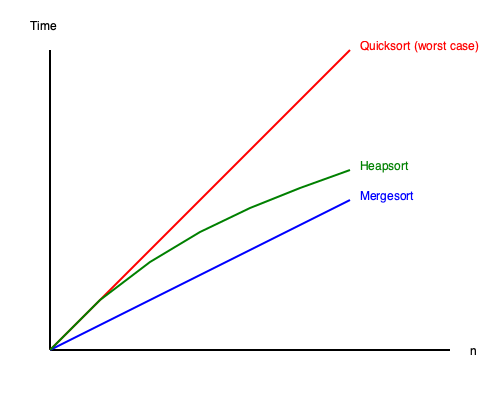Based on the time complexity graph shown, which sorting algorithm would be the most efficient choice for sorting large datasets with unknown distributions, and why? To answer this question, let's analyze the time complexity of each sorting algorithm shown in the graph:

1. Red line (Quicksort worst case):
   - Shows a steep curve, indicating $O(n^2)$ time complexity in the worst case.
   - This occurs when the pivot selection is consistently poor, such as always choosing the smallest or largest element.

2. Blue line (Mergesort):
   - Displays a more gradual increase, representing $O(n \log n)$ time complexity.
   - Mergesort maintains this time complexity regardless of the input distribution.

3. Green line (Heapsort):
   - Also shows a gradual increase, similar to Mergesort, indicating $O(n \log n)$ time complexity.
   - Heapsort, like Mergesort, maintains this time complexity for all input distributions.

For large datasets with unknown distributions:

1. Quicksort is risky because its worst-case time complexity is $O(n^2)$, which could lead to poor performance if the data happens to be in an unfavorable order.

2. Mergesort and Heapsort both guarantee $O(n \log n)$ time complexity regardless of the input distribution.

3. Between Mergesort and Heapsort, Heapsort has the advantage of being in-place, requiring $O(1)$ additional space, while Mergesort typically requires $O(n)$ additional space.

Therefore, Heapsort would be the most efficient choice for sorting large datasets with unknown distributions. It guarantees $O(n \log n)$ time complexity in all cases, uses less additional memory than Mergesort, and avoids the risk of degrading to $O(n^2)$ performance like Quicksort in its worst case.
Answer: Heapsort 